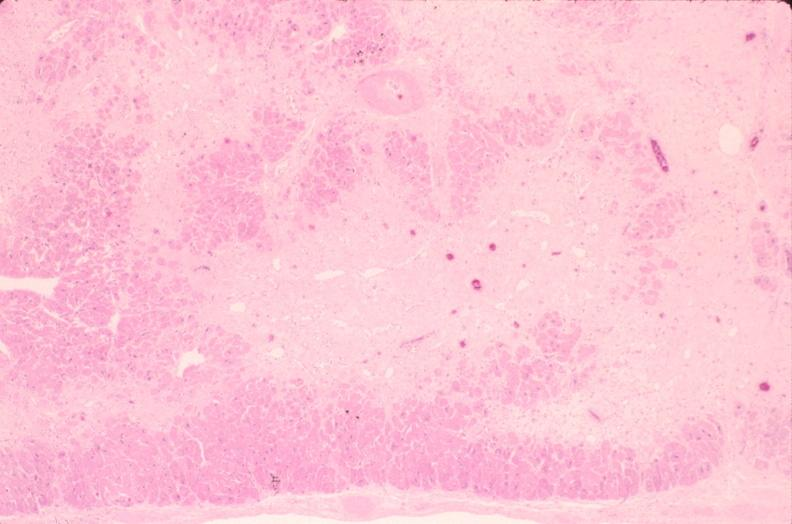s cardiovascular present?
Answer the question using a single word or phrase. Yes 